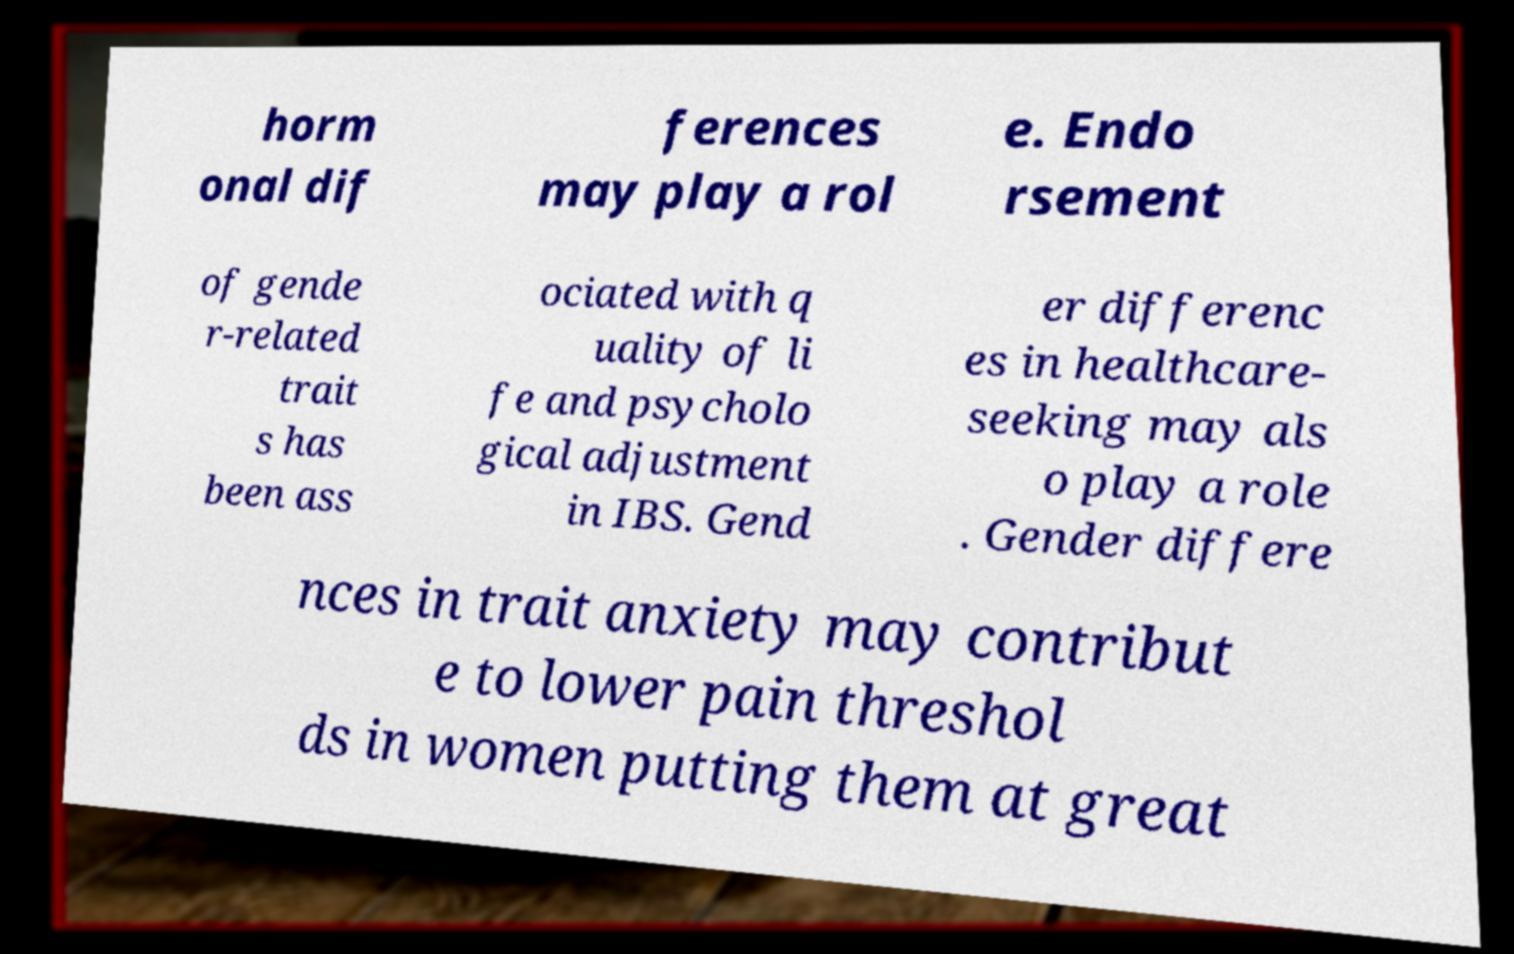Could you assist in decoding the text presented in this image and type it out clearly? horm onal dif ferences may play a rol e. Endo rsement of gende r-related trait s has been ass ociated with q uality of li fe and psycholo gical adjustment in IBS. Gend er differenc es in healthcare- seeking may als o play a role . Gender differe nces in trait anxiety may contribut e to lower pain threshol ds in women putting them at great 